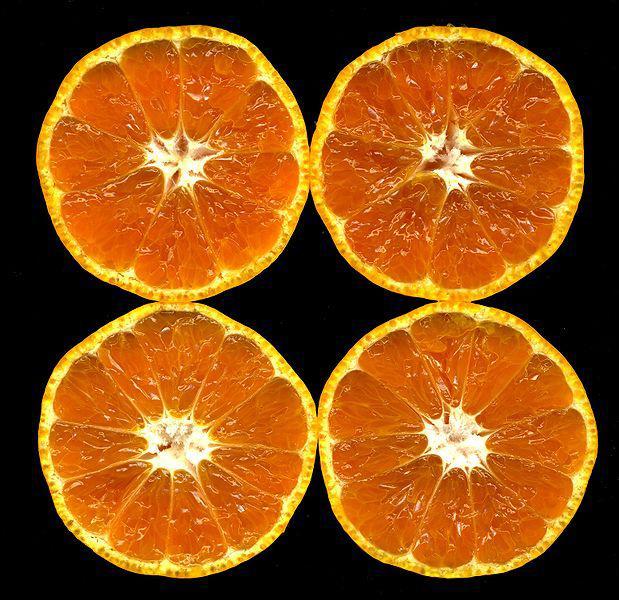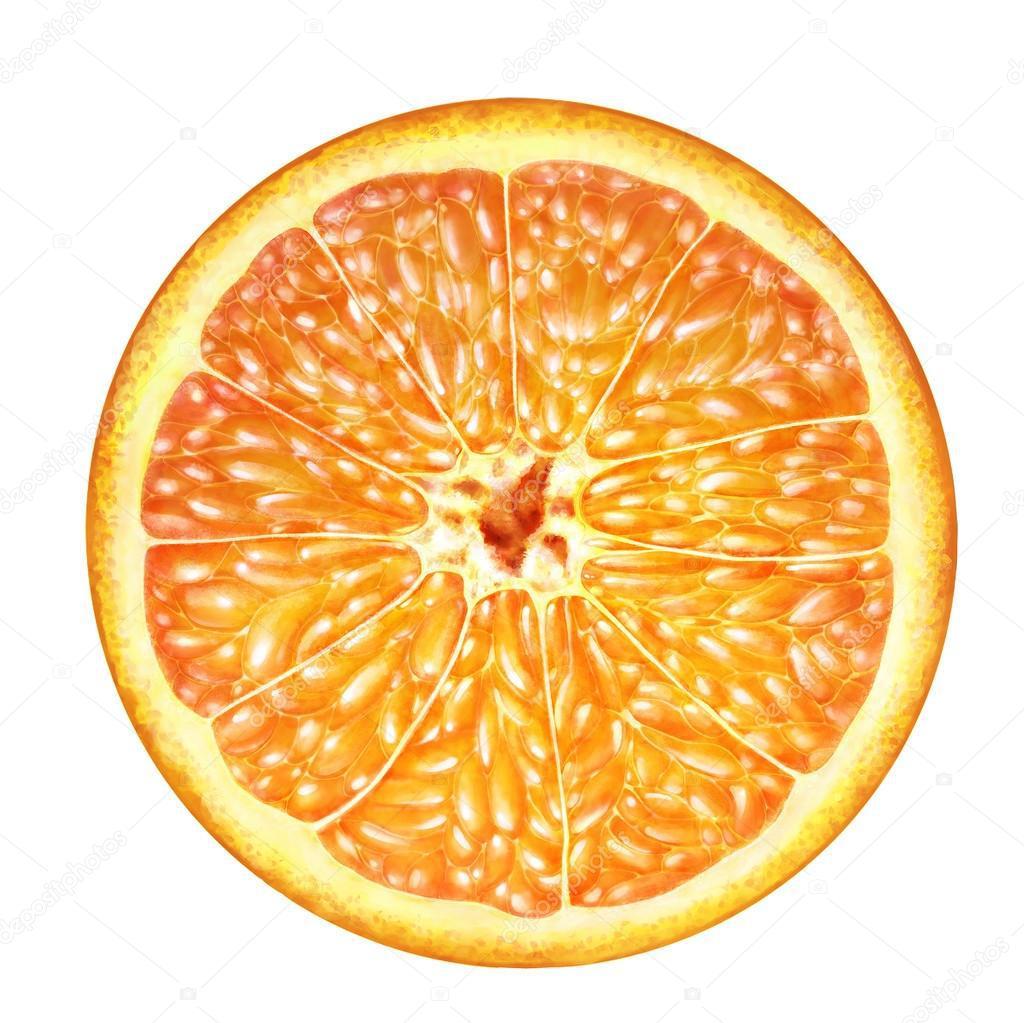The first image is the image on the left, the second image is the image on the right. For the images displayed, is the sentence "Some of the oranges are cut, some are whole." factually correct? Answer yes or no. No. The first image is the image on the left, the second image is the image on the right. For the images shown, is this caption "There is a whole citrus fruit in one of the images." true? Answer yes or no. No. 